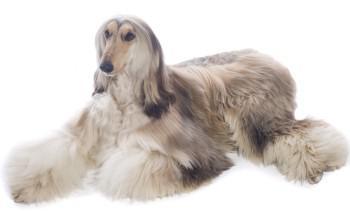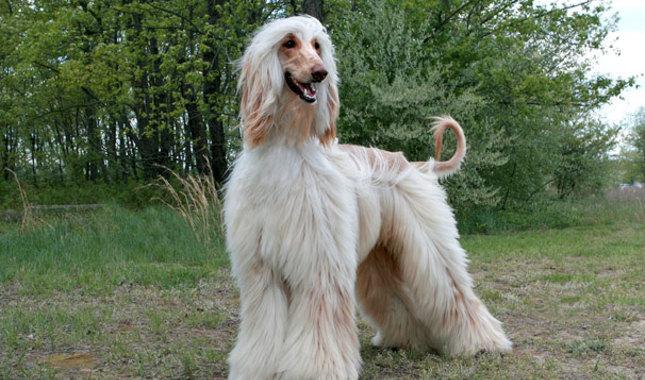The first image is the image on the left, the second image is the image on the right. Examine the images to the left and right. Is the description "In one image there is a lone afghan hound standing outside" accurate? Answer yes or no. Yes. The first image is the image on the left, the second image is the image on the right. Assess this claim about the two images: "One image has a tan and white dog standing on grass.". Correct or not? Answer yes or no. Yes. 